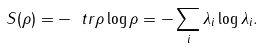Convert formula to latex. <formula><loc_0><loc_0><loc_500><loc_500>S ( \rho ) = - \ t r \rho \log \rho = - \sum _ { i } \lambda _ { i } \log \lambda _ { i } .</formula> 